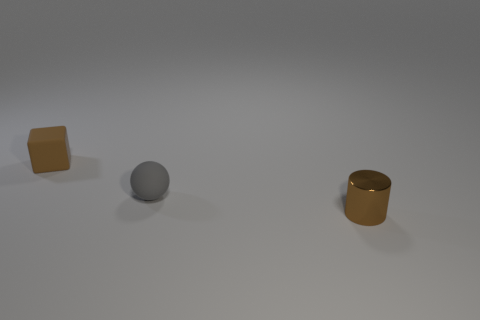Add 2 small brown matte blocks. How many objects exist? 5 Subtract all balls. How many objects are left? 2 Add 1 tiny purple shiny cubes. How many tiny purple shiny cubes exist? 1 Subtract 0 yellow cylinders. How many objects are left? 3 Subtract all gray spheres. Subtract all rubber cubes. How many objects are left? 1 Add 3 spheres. How many spheres are left? 4 